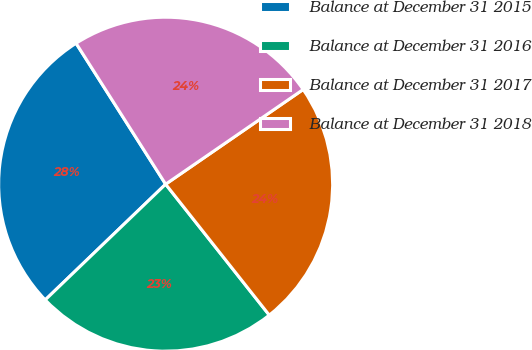Convert chart to OTSL. <chart><loc_0><loc_0><loc_500><loc_500><pie_chart><fcel>Balance at December 31 2015<fcel>Balance at December 31 2016<fcel>Balance at December 31 2017<fcel>Balance at December 31 2018<nl><fcel>28.17%<fcel>23.47%<fcel>23.94%<fcel>24.41%<nl></chart> 